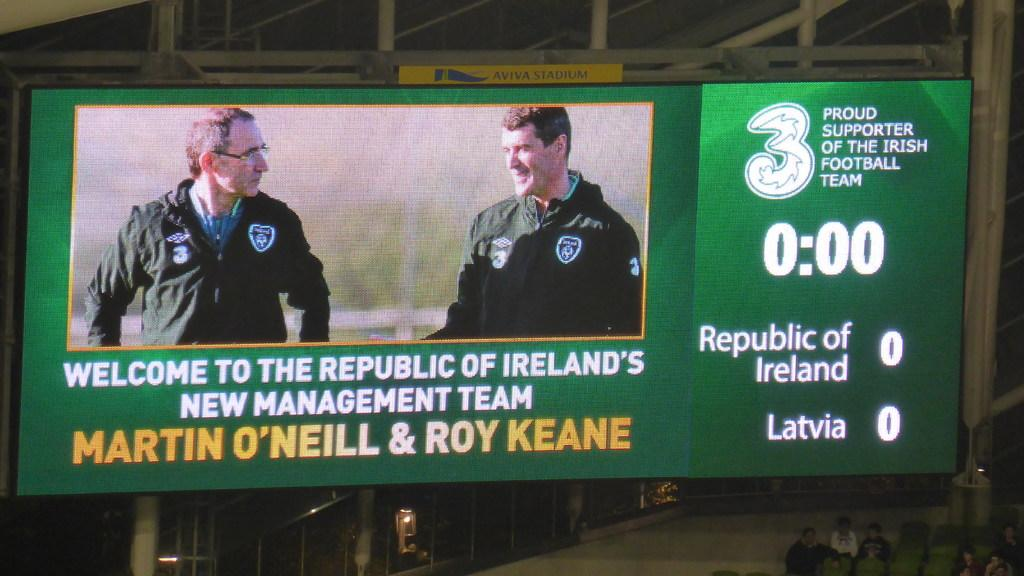<image>
Present a compact description of the photo's key features. Green scoreboard with Proud supporter of the irish football team in white. 